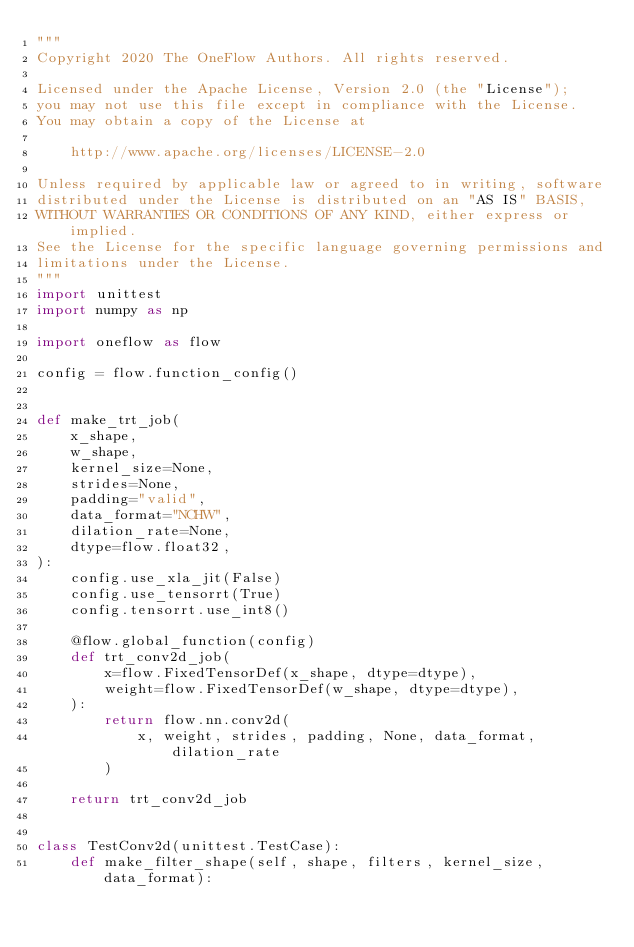Convert code to text. <code><loc_0><loc_0><loc_500><loc_500><_Python_>"""
Copyright 2020 The OneFlow Authors. All rights reserved.

Licensed under the Apache License, Version 2.0 (the "License");
you may not use this file except in compliance with the License.
You may obtain a copy of the License at

    http://www.apache.org/licenses/LICENSE-2.0

Unless required by applicable law or agreed to in writing, software
distributed under the License is distributed on an "AS IS" BASIS,
WITHOUT WARRANTIES OR CONDITIONS OF ANY KIND, either express or implied.
See the License for the specific language governing permissions and
limitations under the License.
"""
import unittest
import numpy as np

import oneflow as flow

config = flow.function_config()


def make_trt_job(
    x_shape,
    w_shape,
    kernel_size=None,
    strides=None,
    padding="valid",
    data_format="NCHW",
    dilation_rate=None,
    dtype=flow.float32,
):
    config.use_xla_jit(False)
    config.use_tensorrt(True)
    config.tensorrt.use_int8()

    @flow.global_function(config)
    def trt_conv2d_job(
        x=flow.FixedTensorDef(x_shape, dtype=dtype),
        weight=flow.FixedTensorDef(w_shape, dtype=dtype),
    ):
        return flow.nn.conv2d(
            x, weight, strides, padding, None, data_format, dilation_rate
        )

    return trt_conv2d_job


class TestConv2d(unittest.TestCase):
    def make_filter_shape(self, shape, filters, kernel_size, data_format):</code> 